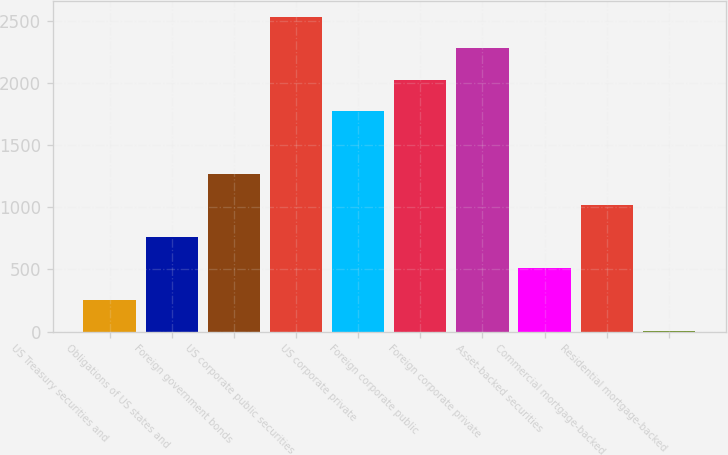<chart> <loc_0><loc_0><loc_500><loc_500><bar_chart><fcel>US Treasury securities and<fcel>Obligations of US states and<fcel>Foreign government bonds<fcel>US corporate public securities<fcel>US corporate private<fcel>Foreign corporate public<fcel>Foreign corporate private<fcel>Asset-backed securities<fcel>Commercial mortgage-backed<fcel>Residential mortgage-backed<nl><fcel>256.7<fcel>762.1<fcel>1267.5<fcel>2531<fcel>1772.9<fcel>2025.6<fcel>2278.3<fcel>509.4<fcel>1014.8<fcel>4<nl></chart> 